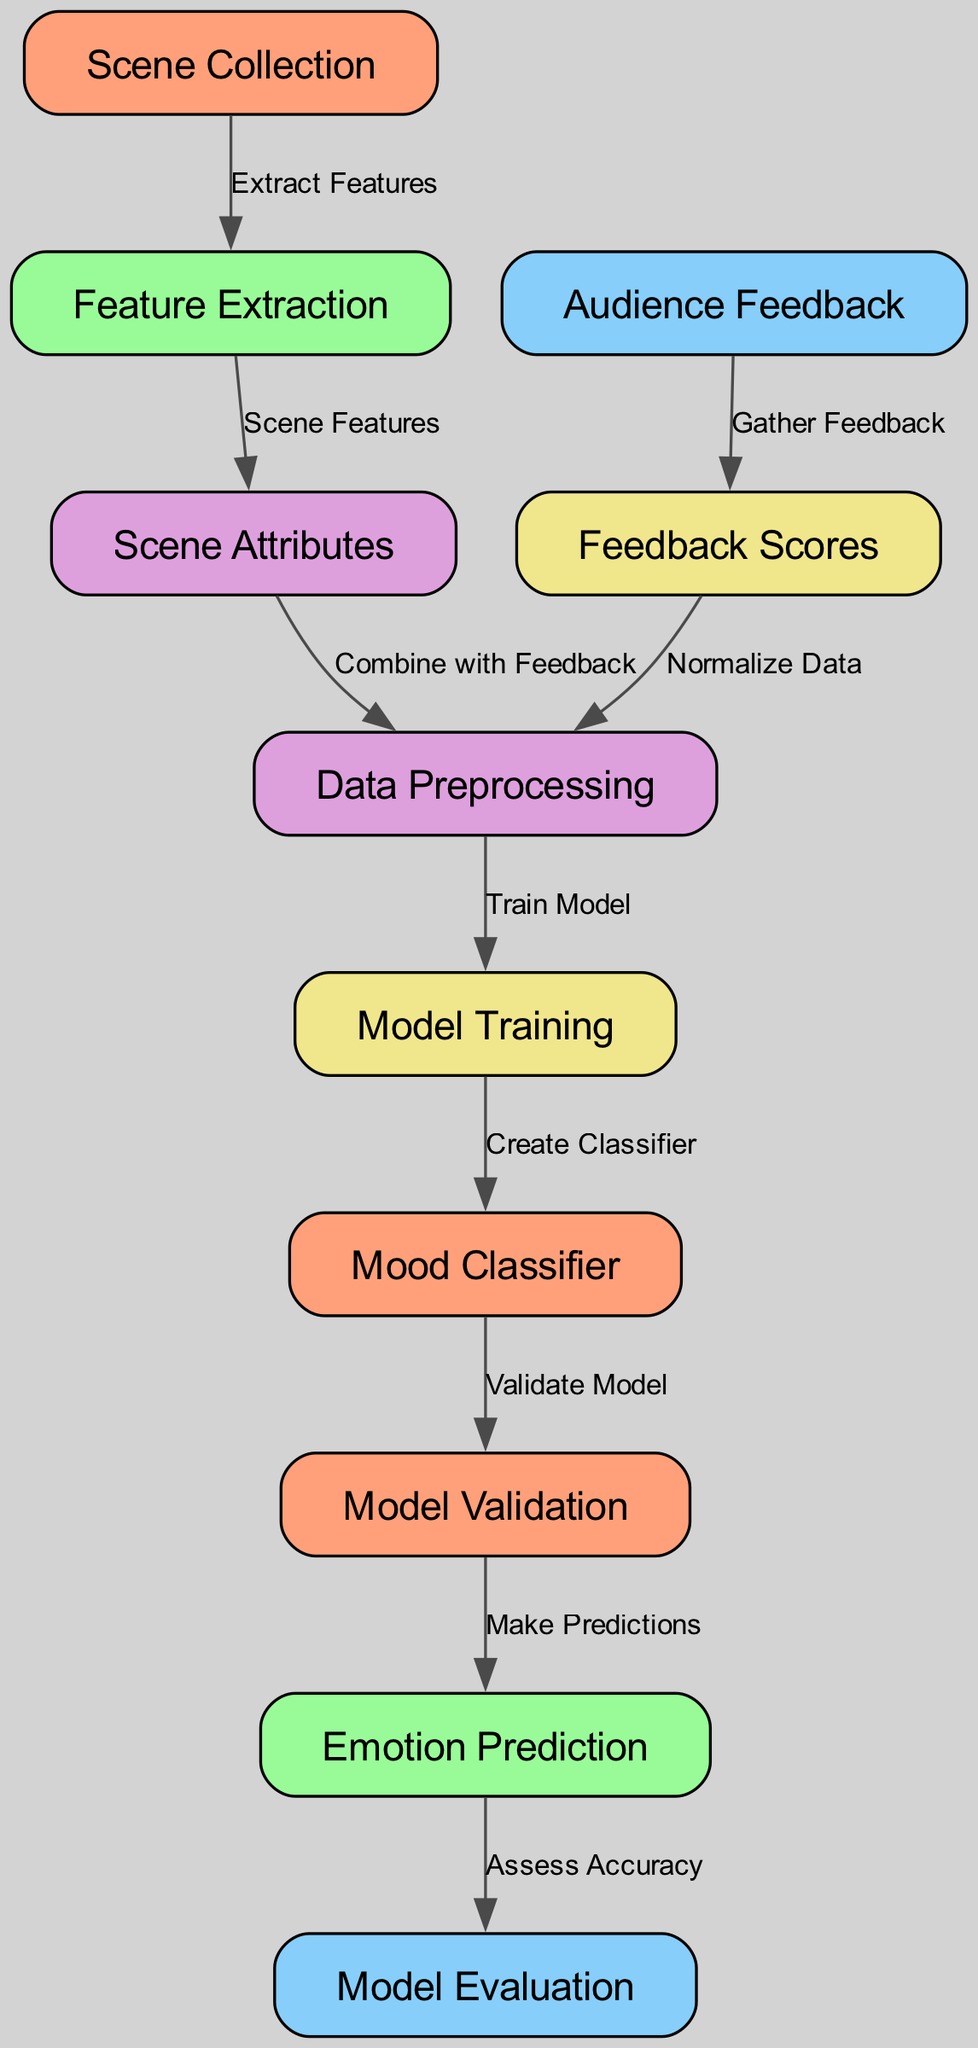What's the total number of nodes in the diagram? Counting all the nodes provided in the diagram data section, we find there are 11 nodes labeled as: Scene Collection, Feature Extraction, Audience Feedback, Data Preprocessing, Model Training, Model Validation, Emotion Prediction, Model Evaluation, Scene Attributes, Feedback Scores, and Mood Classifier.
Answer: 11 Which node comes after ‘Feature Extraction’? According to the diagram structure, 'Feature Extraction' leads to 'Scene Attributes', meaning that 'Scene Attributes' is the subsequent node in the flow after 'Feature Extraction'.
Answer: Scene Attributes What is the label of the node linked to Audience Feedback? The diagram indicates that 'Audience Feedback' is connected to 'Feedback Scores', making 'Feedback Scores' the node linked to 'Audience Feedback'.
Answer: Feedback Scores How many edges connect the nodes in the diagram? By reviewing the edge information in the diagram, it's evident that there are 10 edges that represent the connections and relationships between the various nodes.
Answer: 10 From which node does the ‘Preprocessing’ node receive its inputs? The 'Preprocessing' node receives input from two nodes: 'Scene Attributes' and 'Feedback Scores'. Therefore, it combines the output from these two nodes to carry out its function.
Answer: Scene Attributes, Feedback Scores What is the first step in the model workflow? The diagram shows that 'Scene Collection' is the starting point and first step in the machine learning model workflow, as it is the initial node where the process begins.
Answer: Scene Collection Which node provides the final assessment of the model? The diagram indicates that 'Model Evaluation' is the final node in the workflow, where the model's predictions are assessed for accuracy and effectiveness.
Answer: Model Evaluation How does the 'Mood Classifier' contribute to the overall model? The 'Mood Classifier' is vital as it is responsible for creating the classifier after the training phase, which then informs the subsequent validation and prediction processes.
Answer: Create Classifier What is a necessary step before moving from Validation to Emotion Prediction? The diagram illustrates that after 'Validation', the next step is to make predictions in the 'Emotion Prediction' node, meaning that validation needs to be completed prior to this action.
Answer: Make Predictions What action follows ‘Emotion Prediction’? Based on the diagram, the action that follows 'Emotion Prediction' is 'Model Evaluation', where the accuracy of the predictions is assessed.
Answer: Model Evaluation 